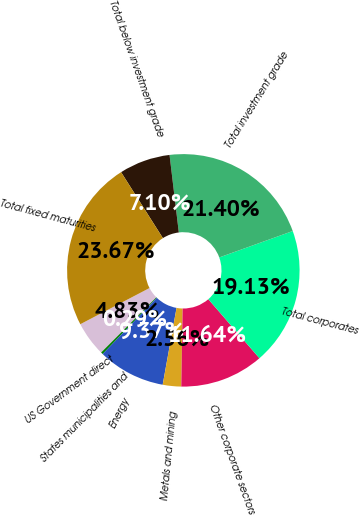Convert chart. <chart><loc_0><loc_0><loc_500><loc_500><pie_chart><fcel>US Government direct<fcel>States municipalities and<fcel>Energy<fcel>Metals and mining<fcel>Other corporate sectors<fcel>Total corporates<fcel>Total investment grade<fcel>Total below investment grade<fcel>Total fixed maturities<nl><fcel>4.83%<fcel>0.29%<fcel>9.37%<fcel>2.56%<fcel>11.64%<fcel>19.13%<fcel>21.4%<fcel>7.1%<fcel>23.67%<nl></chart> 